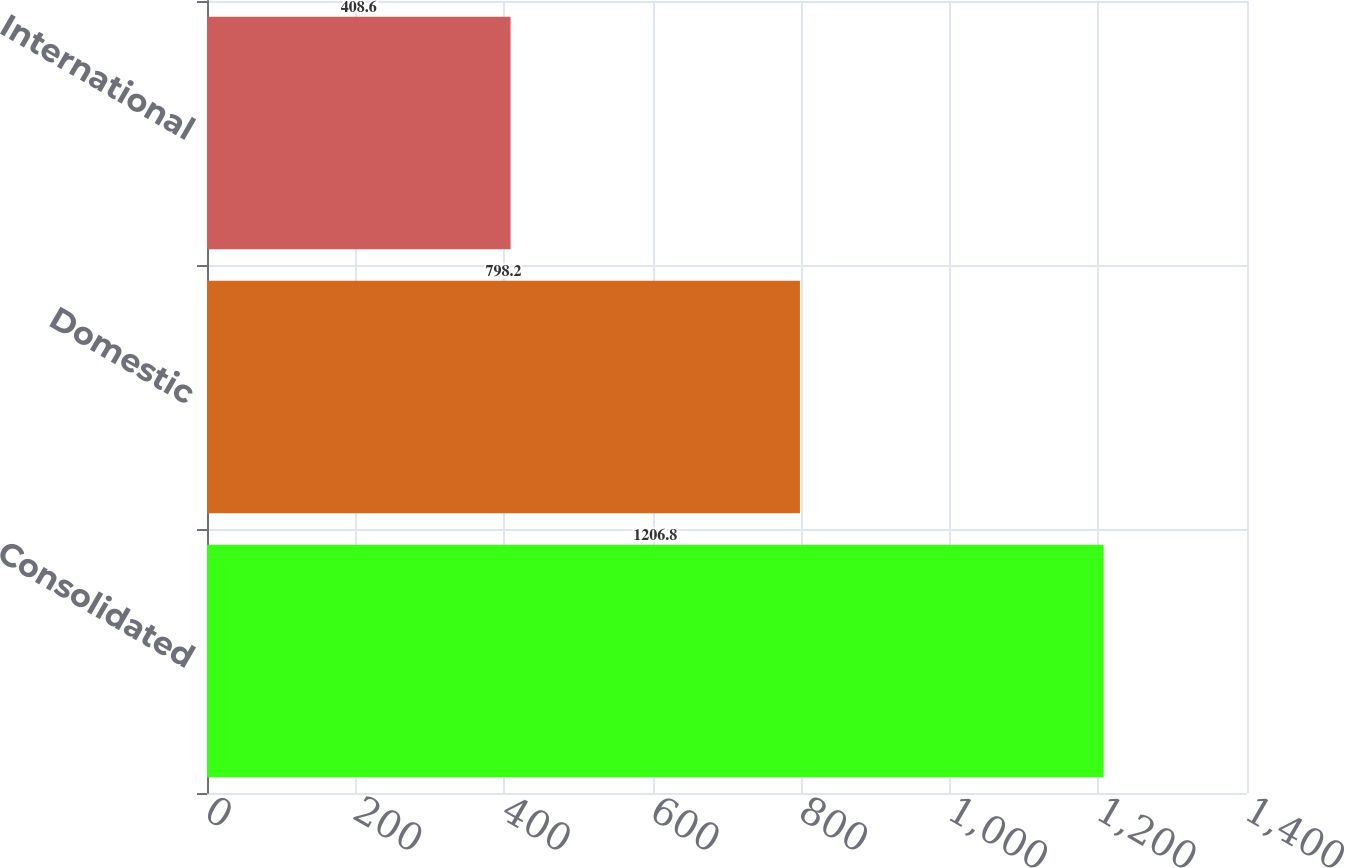<chart> <loc_0><loc_0><loc_500><loc_500><bar_chart><fcel>Consolidated<fcel>Domestic<fcel>International<nl><fcel>1206.8<fcel>798.2<fcel>408.6<nl></chart> 